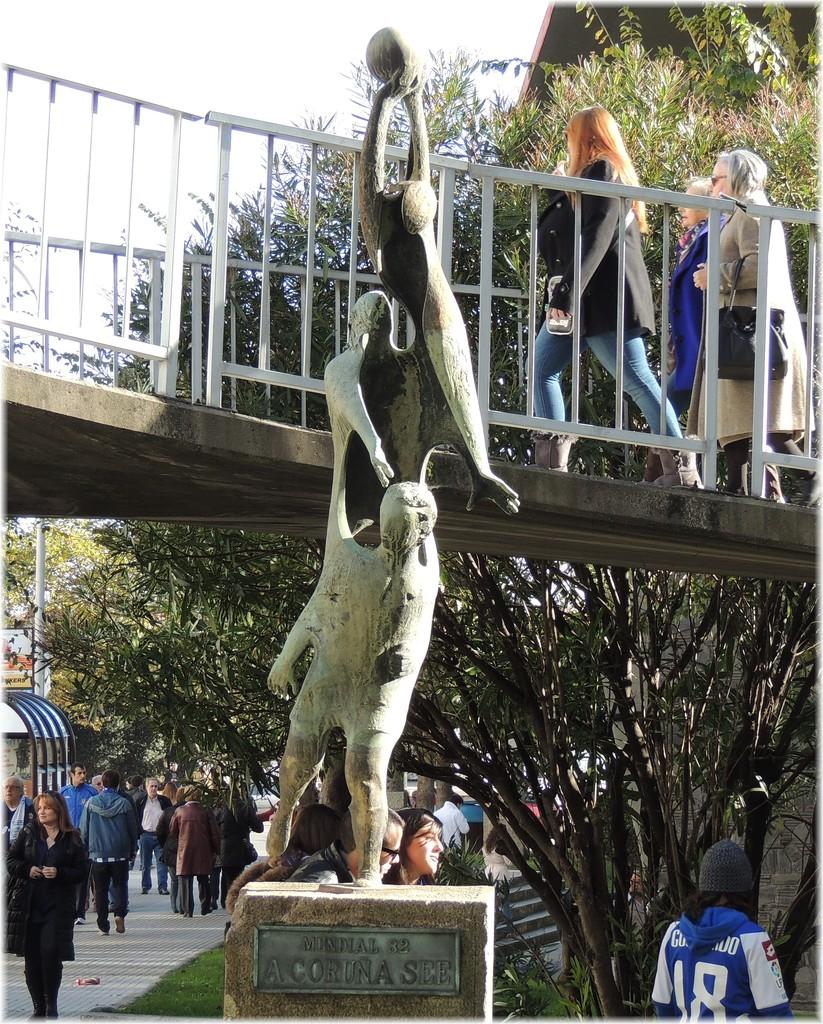What is the number on the blue jersey?
Your answer should be very brief. 18. What number is on the plaque?
Your answer should be compact. 82. 